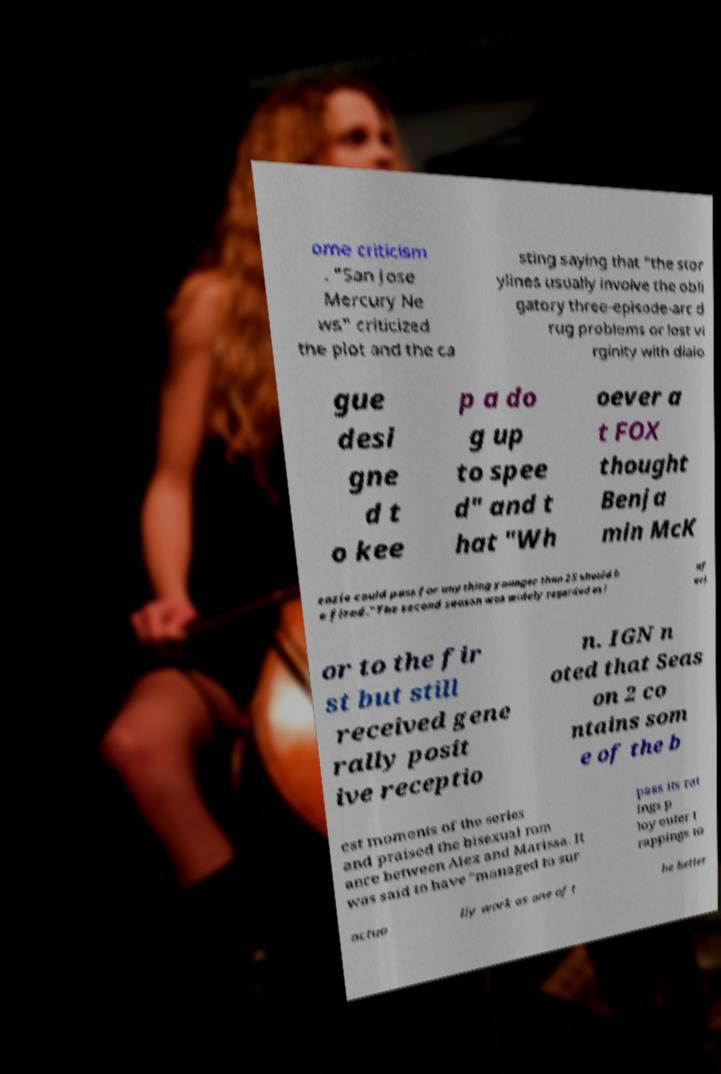Could you assist in decoding the text presented in this image and type it out clearly? ome criticism . "San Jose Mercury Ne ws" criticized the plot and the ca sting saying that "the stor ylines usually involve the obli gatory three-episode-arc d rug problems or lost vi rginity with dialo gue desi gne d t o kee p a do g up to spee d" and t hat "Wh oever a t FOX thought Benja min McK enzie could pass for anything younger than 25 should b e fired."The second season was widely regarded as i nf eri or to the fir st but still received gene rally posit ive receptio n. IGN n oted that Seas on 2 co ntains som e of the b est moments of the series and praised the bisexual rom ance between Alex and Marissa. It was said to have "managed to sur pass its rat ings p loy outer t rappings to actua lly work as one of t he better 